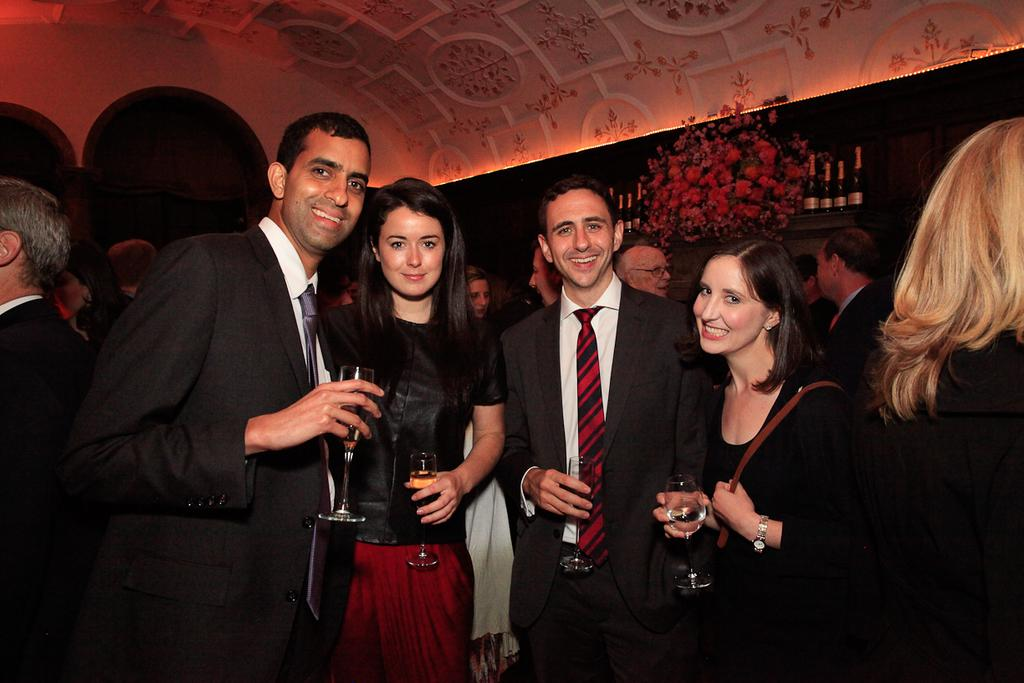Who or what is present in the image? There are people in the image. What are the people wearing? The people are wearing black color dresses. What are the people holding in their hands? The people are holding glasses. What can be seen in the background of the image? There is a wall in the image. What type of decorative elements are present in the image? There are flowers in the image. How does the wax melt in the image? There is no wax present in the image, so it cannot melt. What type of request can be heard from the people in the image? There is no indication of any request being made in the image, as it only shows people wearing black dresses and holding glasses. 